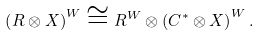<formula> <loc_0><loc_0><loc_500><loc_500>\left ( R \otimes X \right ) ^ { W } \cong R ^ { W } \otimes \left ( C ^ { * } \otimes X \right ) ^ { W } .</formula> 